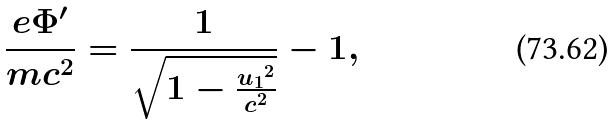<formula> <loc_0><loc_0><loc_500><loc_500>\frac { e \Phi ^ { \prime } } { m c ^ { 2 } } = \frac { 1 } { \sqrt { 1 - \frac { { u _ { 1 } } ^ { 2 } } { c ^ { 2 } } } } - 1 ,</formula> 